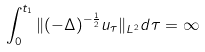Convert formula to latex. <formula><loc_0><loc_0><loc_500><loc_500>\int _ { 0 } ^ { t _ { 1 } } \| ( - \Delta ) ^ { - \frac { 1 } { 2 } } u _ { \tau } \| _ { L ^ { 2 } } d \tau = \infty</formula> 